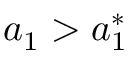Convert formula to latex. <formula><loc_0><loc_0><loc_500><loc_500>a _ { 1 } > a _ { 1 } ^ { * }</formula> 